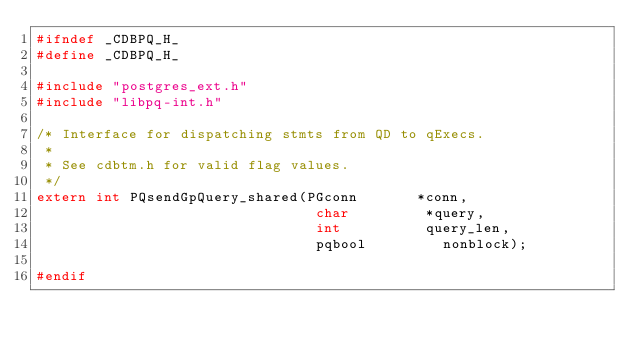<code> <loc_0><loc_0><loc_500><loc_500><_C_>#ifndef _CDBPQ_H_
#define _CDBPQ_H_

#include "postgres_ext.h"
#include "libpq-int.h"

/* Interface for dispatching stmts from QD to qExecs.
 *
 * See cdbtm.h for valid flag values.
 */
extern int PQsendGpQuery_shared(PGconn       *conn,
								 char         *query,
								 int          query_len,
								 pqbool         nonblock);

#endif
</code> 